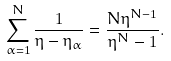<formula> <loc_0><loc_0><loc_500><loc_500>\sum _ { \alpha = 1 } ^ { N } \frac { 1 } { \eta - \eta _ { \alpha } } = \frac { N \eta ^ { N - 1 } } { \eta ^ { N } - 1 } .</formula> 